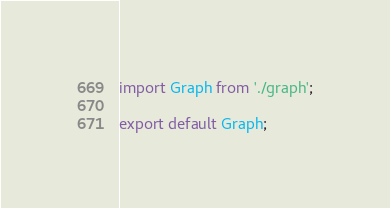Convert code to text. <code><loc_0><loc_0><loc_500><loc_500><_JavaScript_>import Graph from './graph';

export default Graph;
</code> 